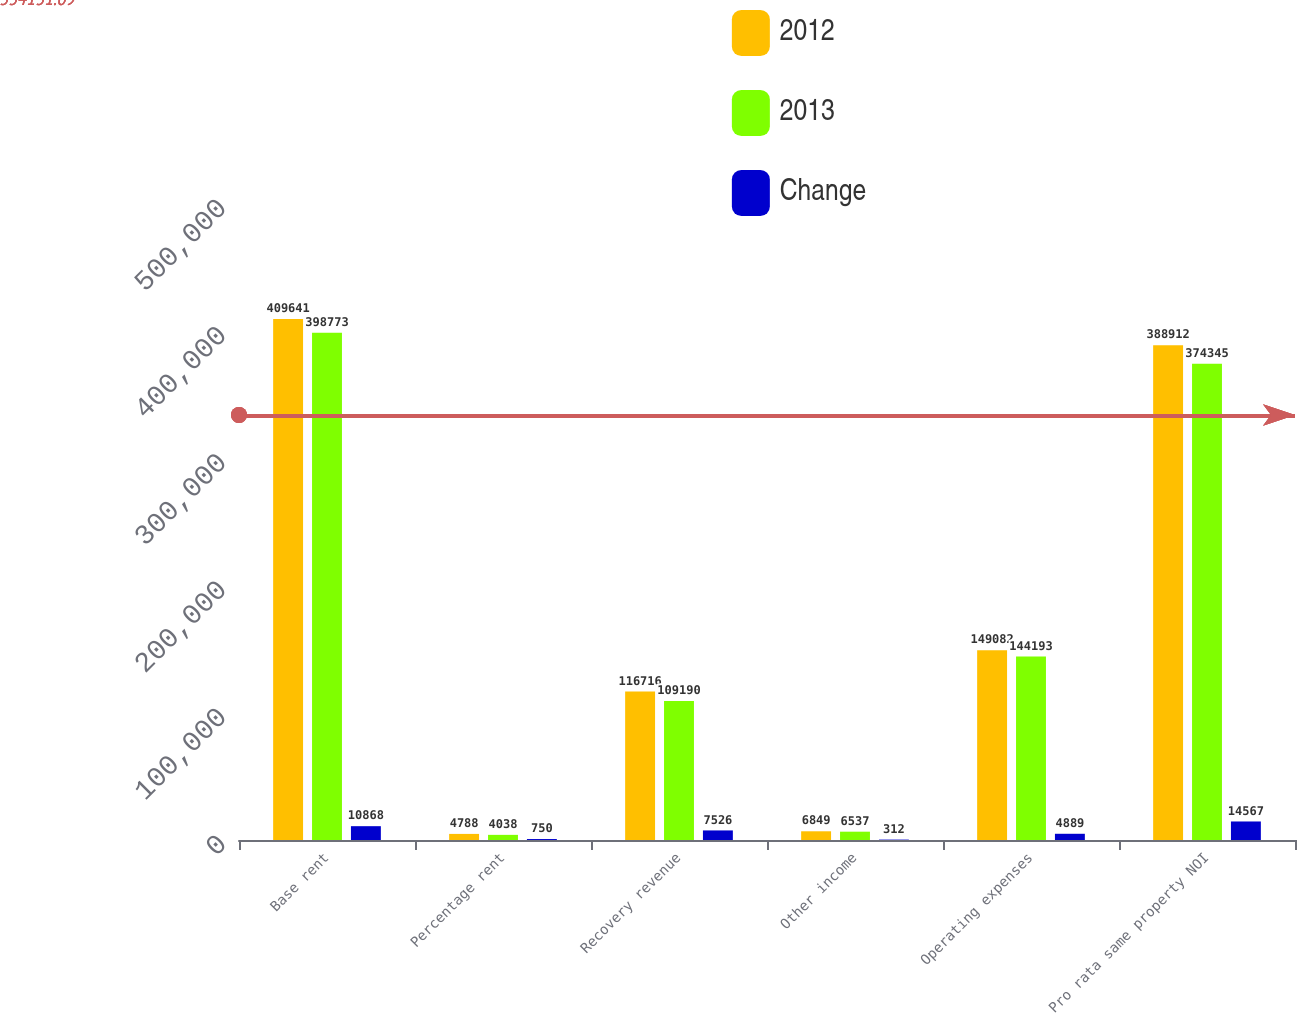Convert chart to OTSL. <chart><loc_0><loc_0><loc_500><loc_500><stacked_bar_chart><ecel><fcel>Base rent<fcel>Percentage rent<fcel>Recovery revenue<fcel>Other income<fcel>Operating expenses<fcel>Pro rata same property NOI<nl><fcel>2012<fcel>409641<fcel>4788<fcel>116716<fcel>6849<fcel>149082<fcel>388912<nl><fcel>2013<fcel>398773<fcel>4038<fcel>109190<fcel>6537<fcel>144193<fcel>374345<nl><fcel>Change<fcel>10868<fcel>750<fcel>7526<fcel>312<fcel>4889<fcel>14567<nl></chart> 